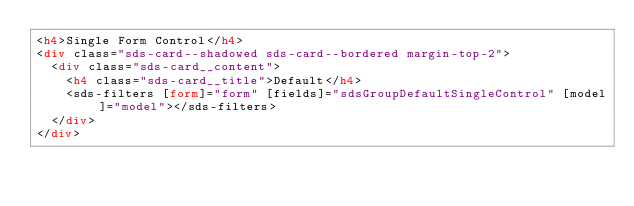<code> <loc_0><loc_0><loc_500><loc_500><_HTML_><h4>Single Form Control</h4>
<div class="sds-card--shadowed sds-card--bordered margin-top-2">
  <div class="sds-card__content">
    <h4 class="sds-card__title">Default</h4>
    <sds-filters [form]="form" [fields]="sdsGroupDefaultSingleControl" [model]="model"></sds-filters>
  </div>
</div>
</code> 